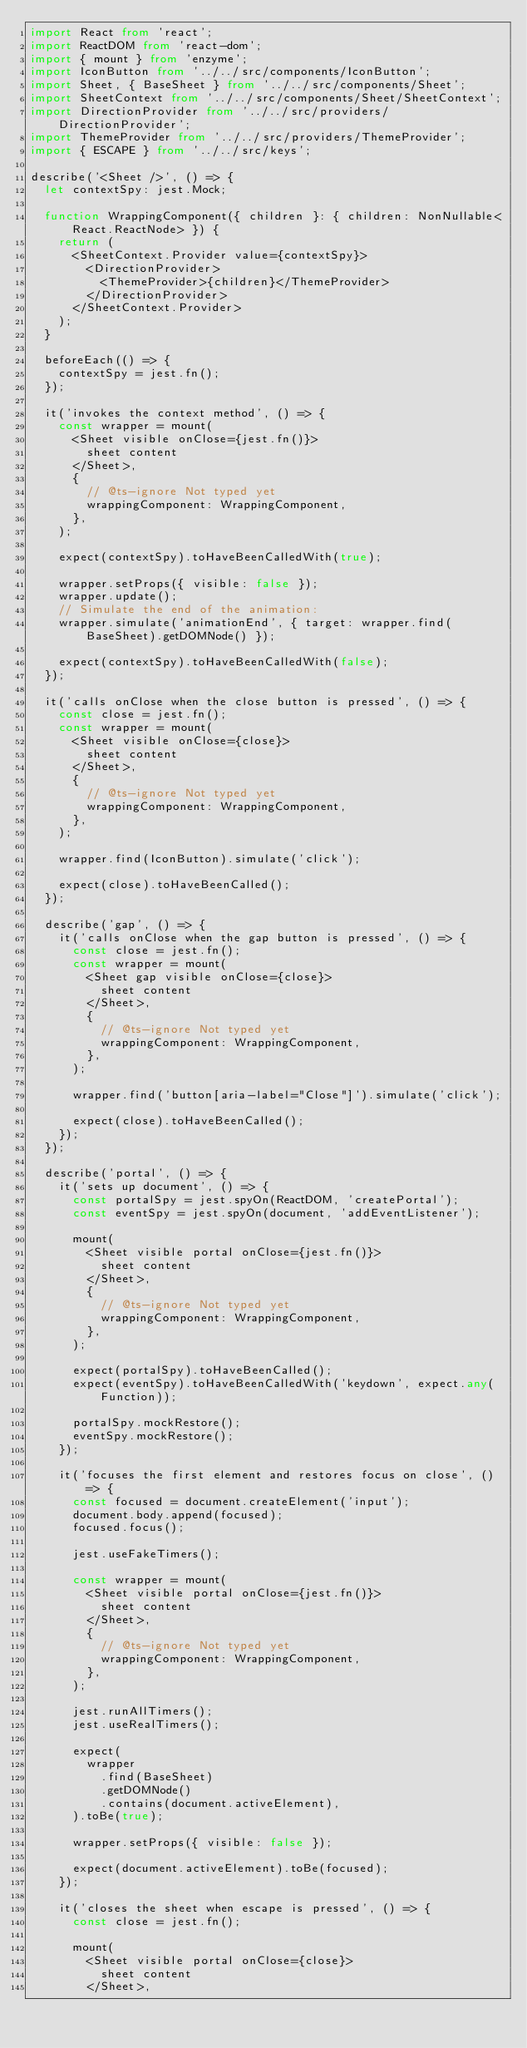Convert code to text. <code><loc_0><loc_0><loc_500><loc_500><_TypeScript_>import React from 'react';
import ReactDOM from 'react-dom';
import { mount } from 'enzyme';
import IconButton from '../../src/components/IconButton';
import Sheet, { BaseSheet } from '../../src/components/Sheet';
import SheetContext from '../../src/components/Sheet/SheetContext';
import DirectionProvider from '../../src/providers/DirectionProvider';
import ThemeProvider from '../../src/providers/ThemeProvider';
import { ESCAPE } from '../../src/keys';

describe('<Sheet />', () => {
  let contextSpy: jest.Mock;

  function WrappingComponent({ children }: { children: NonNullable<React.ReactNode> }) {
    return (
      <SheetContext.Provider value={contextSpy}>
        <DirectionProvider>
          <ThemeProvider>{children}</ThemeProvider>
        </DirectionProvider>
      </SheetContext.Provider>
    );
  }

  beforeEach(() => {
    contextSpy = jest.fn();
  });

  it('invokes the context method', () => {
    const wrapper = mount(
      <Sheet visible onClose={jest.fn()}>
        sheet content
      </Sheet>,
      {
        // @ts-ignore Not typed yet
        wrappingComponent: WrappingComponent,
      },
    );

    expect(contextSpy).toHaveBeenCalledWith(true);

    wrapper.setProps({ visible: false });
    wrapper.update();
    // Simulate the end of the animation:
    wrapper.simulate('animationEnd', { target: wrapper.find(BaseSheet).getDOMNode() });

    expect(contextSpy).toHaveBeenCalledWith(false);
  });

  it('calls onClose when the close button is pressed', () => {
    const close = jest.fn();
    const wrapper = mount(
      <Sheet visible onClose={close}>
        sheet content
      </Sheet>,
      {
        // @ts-ignore Not typed yet
        wrappingComponent: WrappingComponent,
      },
    );

    wrapper.find(IconButton).simulate('click');

    expect(close).toHaveBeenCalled();
  });

  describe('gap', () => {
    it('calls onClose when the gap button is pressed', () => {
      const close = jest.fn();
      const wrapper = mount(
        <Sheet gap visible onClose={close}>
          sheet content
        </Sheet>,
        {
          // @ts-ignore Not typed yet
          wrappingComponent: WrappingComponent,
        },
      );

      wrapper.find('button[aria-label="Close"]').simulate('click');

      expect(close).toHaveBeenCalled();
    });
  });

  describe('portal', () => {
    it('sets up document', () => {
      const portalSpy = jest.spyOn(ReactDOM, 'createPortal');
      const eventSpy = jest.spyOn(document, 'addEventListener');

      mount(
        <Sheet visible portal onClose={jest.fn()}>
          sheet content
        </Sheet>,
        {
          // @ts-ignore Not typed yet
          wrappingComponent: WrappingComponent,
        },
      );

      expect(portalSpy).toHaveBeenCalled();
      expect(eventSpy).toHaveBeenCalledWith('keydown', expect.any(Function));

      portalSpy.mockRestore();
      eventSpy.mockRestore();
    });

    it('focuses the first element and restores focus on close', () => {
      const focused = document.createElement('input');
      document.body.append(focused);
      focused.focus();

      jest.useFakeTimers();

      const wrapper = mount(
        <Sheet visible portal onClose={jest.fn()}>
          sheet content
        </Sheet>,
        {
          // @ts-ignore Not typed yet
          wrappingComponent: WrappingComponent,
        },
      );

      jest.runAllTimers();
      jest.useRealTimers();

      expect(
        wrapper
          .find(BaseSheet)
          .getDOMNode()
          .contains(document.activeElement),
      ).toBe(true);

      wrapper.setProps({ visible: false });

      expect(document.activeElement).toBe(focused);
    });

    it('closes the sheet when escape is pressed', () => {
      const close = jest.fn();

      mount(
        <Sheet visible portal onClose={close}>
          sheet content
        </Sheet>,</code> 